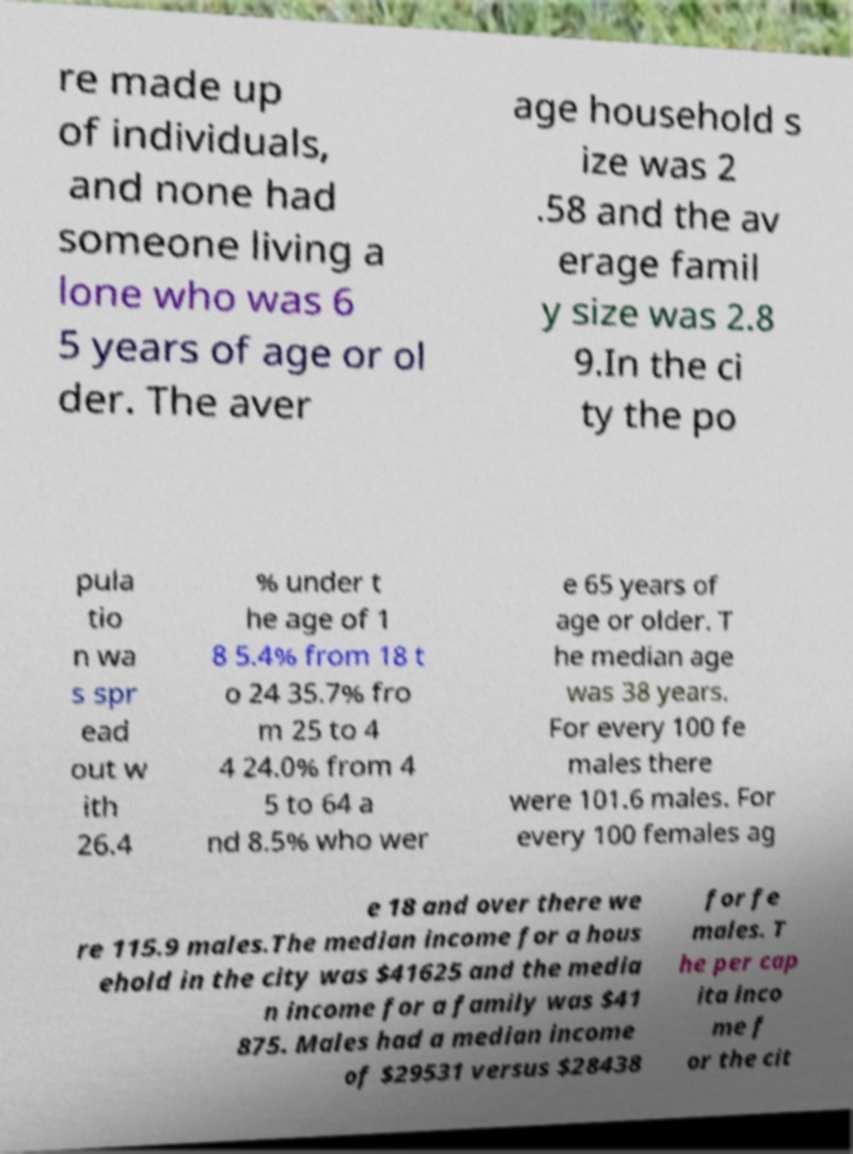Please identify and transcribe the text found in this image. re made up of individuals, and none had someone living a lone who was 6 5 years of age or ol der. The aver age household s ize was 2 .58 and the av erage famil y size was 2.8 9.In the ci ty the po pula tio n wa s spr ead out w ith 26.4 % under t he age of 1 8 5.4% from 18 t o 24 35.7% fro m 25 to 4 4 24.0% from 4 5 to 64 a nd 8.5% who wer e 65 years of age or older. T he median age was 38 years. For every 100 fe males there were 101.6 males. For every 100 females ag e 18 and over there we re 115.9 males.The median income for a hous ehold in the city was $41625 and the media n income for a family was $41 875. Males had a median income of $29531 versus $28438 for fe males. T he per cap ita inco me f or the cit 